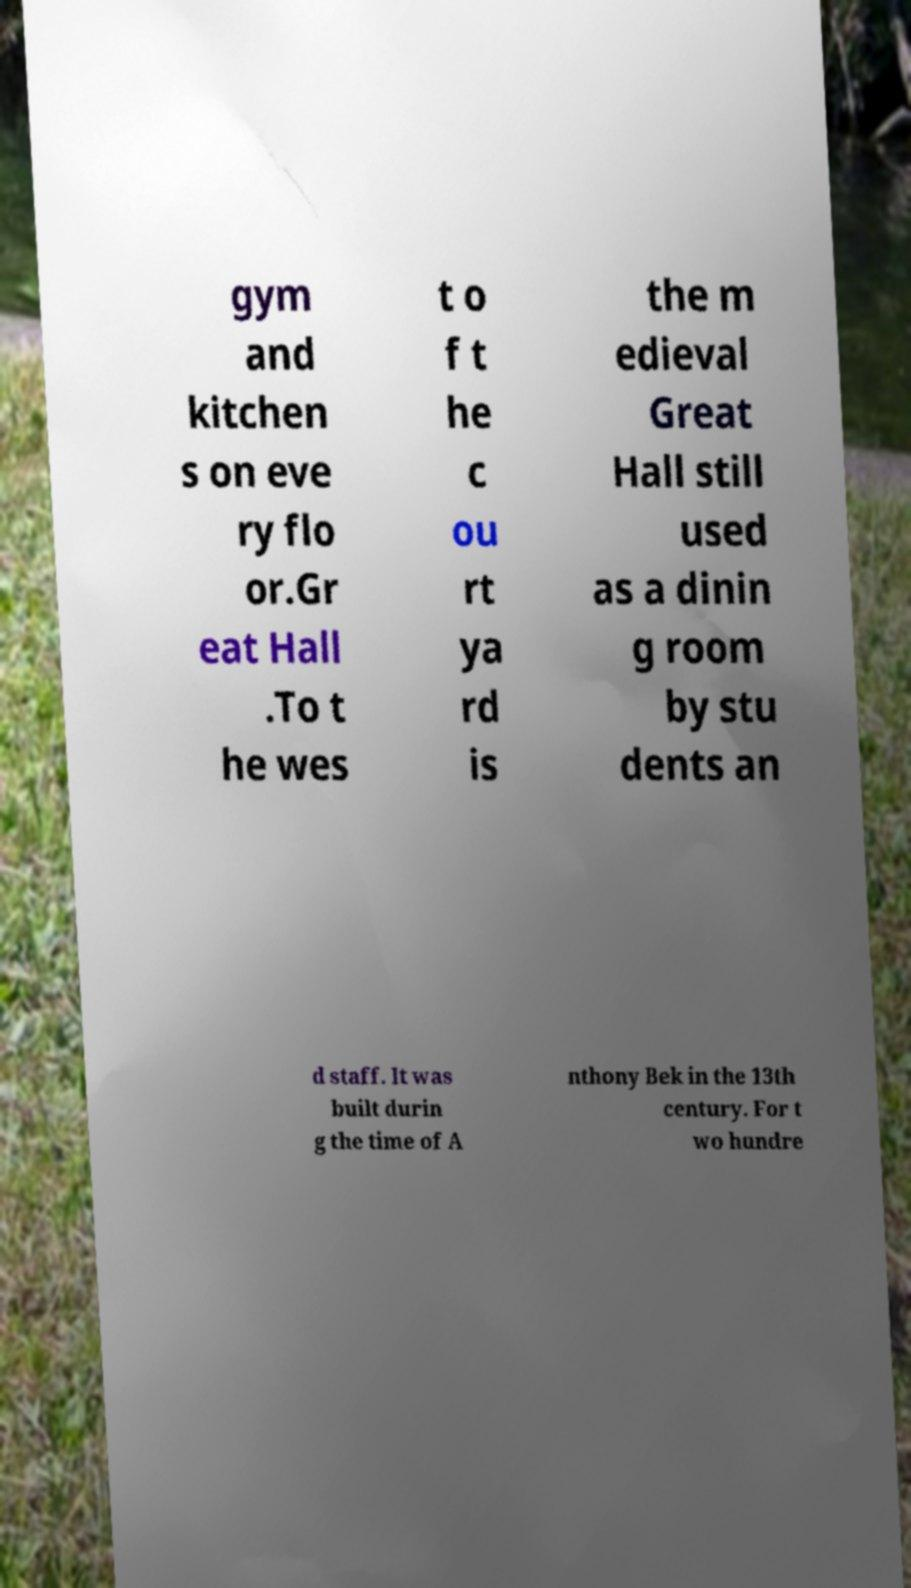There's text embedded in this image that I need extracted. Can you transcribe it verbatim? gym and kitchen s on eve ry flo or.Gr eat Hall .To t he wes t o f t he c ou rt ya rd is the m edieval Great Hall still used as a dinin g room by stu dents an d staff. It was built durin g the time of A nthony Bek in the 13th century. For t wo hundre 